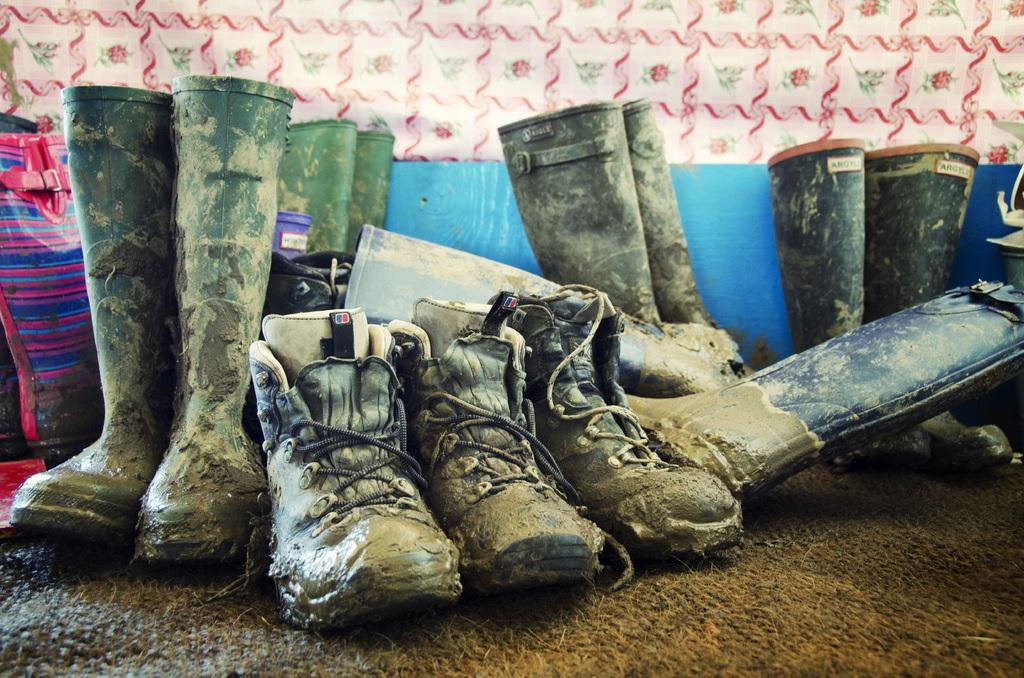What type of footwear is visible in the image? There are boots in the image. What is the boots placed on? There is a mat in the image. What might be used to cover or decorate a window or door in the image? There is a cloth, possibly a curtain, at the top of the image. What object is located on the left side of the image? There is a bag on the left side of the image. What type of corn is growing in the image? There is no corn present in the image. What kind of bulb is illuminating the area in the image? There is no bulb present in the image. 